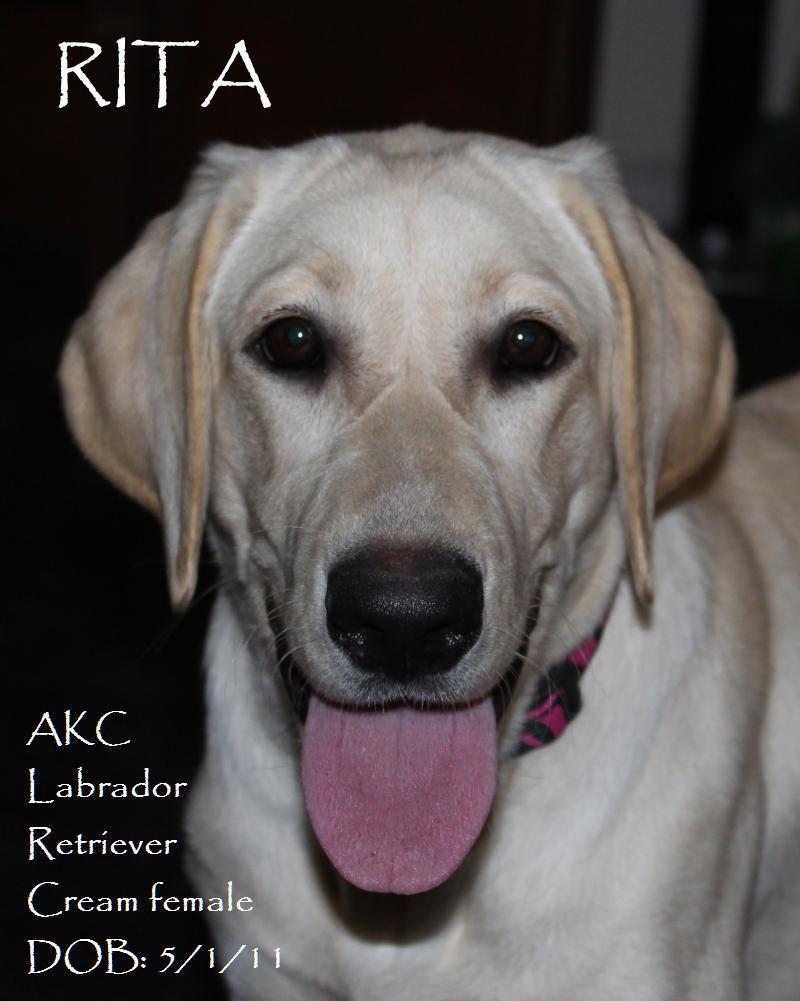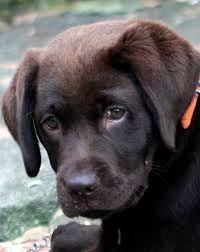The first image is the image on the left, the second image is the image on the right. Given the left and right images, does the statement "One of the images shows a dog with its tongue sticking out." hold true? Answer yes or no. Yes. The first image is the image on the left, the second image is the image on the right. Assess this claim about the two images: "Both images are a head shot of one dog with its mouth closed.". Correct or not? Answer yes or no. No. 